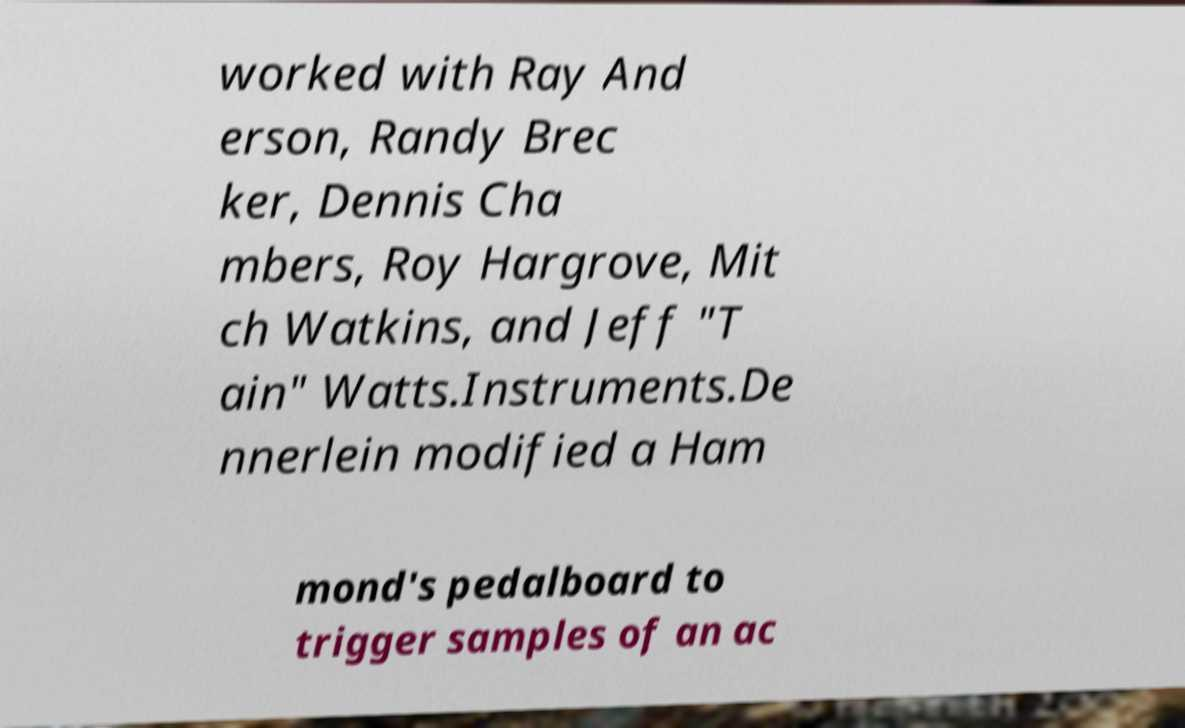What messages or text are displayed in this image? I need them in a readable, typed format. worked with Ray And erson, Randy Brec ker, Dennis Cha mbers, Roy Hargrove, Mit ch Watkins, and Jeff "T ain" Watts.Instruments.De nnerlein modified a Ham mond's pedalboard to trigger samples of an ac 